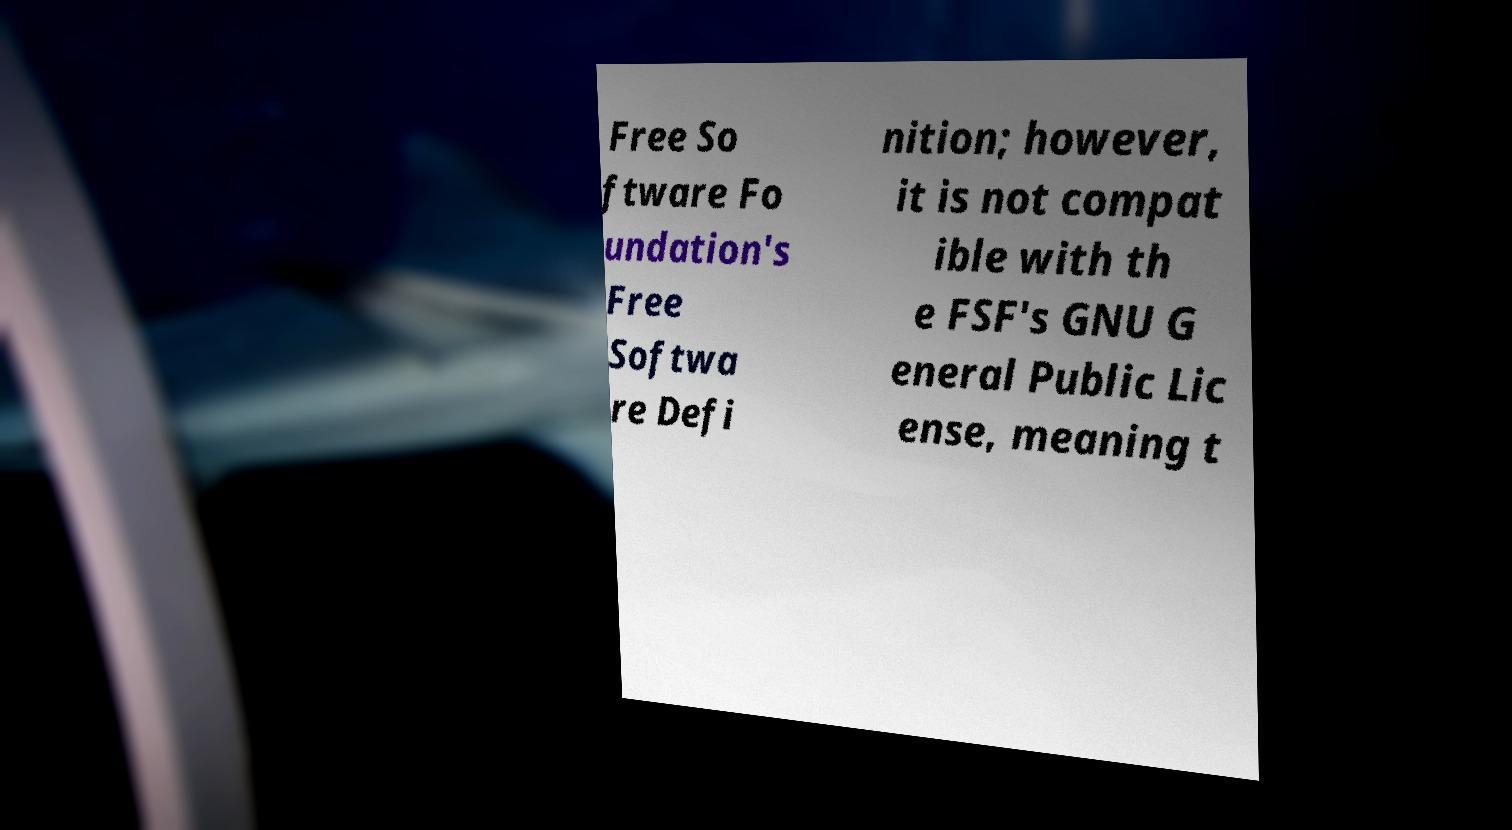Could you assist in decoding the text presented in this image and type it out clearly? Free So ftware Fo undation's Free Softwa re Defi nition; however, it is not compat ible with th e FSF's GNU G eneral Public Lic ense, meaning t 